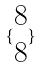<formula> <loc_0><loc_0><loc_500><loc_500>\{ \begin{matrix} 8 \\ 8 \end{matrix} \}</formula> 